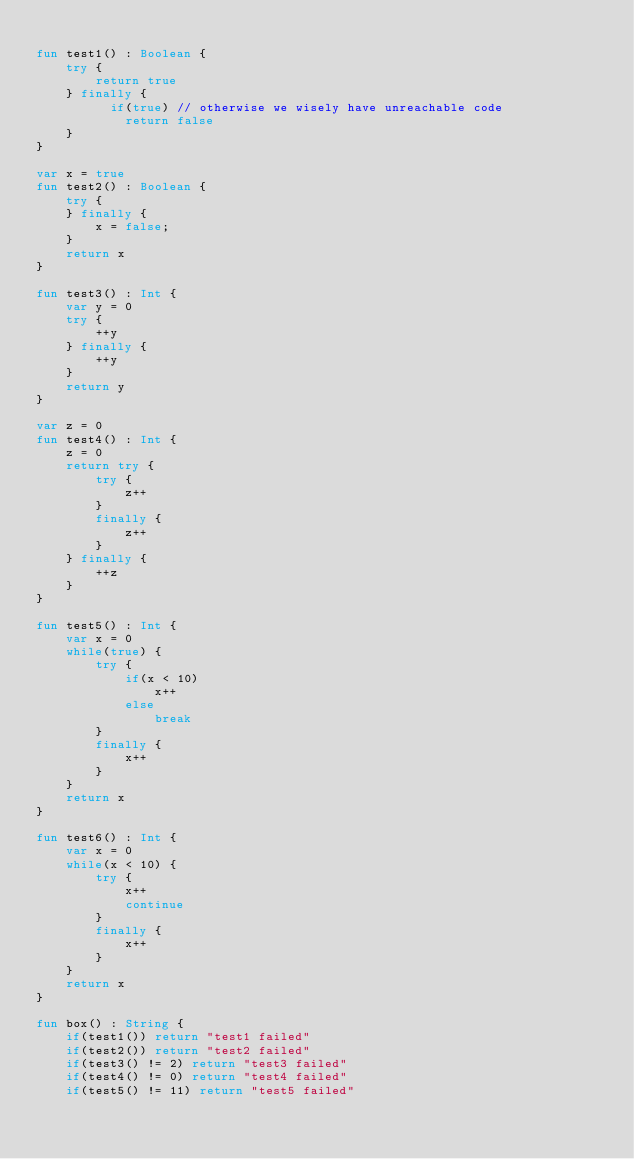Convert code to text. <code><loc_0><loc_0><loc_500><loc_500><_Kotlin_>
fun test1() : Boolean {
    try {
        return true
    } finally {
          if(true) // otherwise we wisely have unreachable code
            return false
    }
}

var x = true
fun test2() : Boolean {
    try {
    } finally {
        x = false;
    }
    return x
}

fun test3() : Int {
    var y = 0
    try {
        ++y
    } finally {
        ++y
    }
    return y
}

var z = 0
fun test4() : Int {
    z = 0
    return try {
        try {
            z++
        }
        finally {
            z++
        }
    } finally {
        ++z
    }
}

fun test5() : Int {
    var x = 0
    while(true) {
        try {
            if(x < 10)
                x++
            else
                break
        }
        finally {
            x++
        }
    }
    return x
}

fun test6() : Int {
    var x = 0
    while(x < 10) {
        try {
            x++
            continue
        }
        finally {
            x++
        }
    }
    return x
}

fun box() : String {
    if(test1()) return "test1 failed"
    if(test2()) return "test2 failed"
    if(test3() != 2) return "test3 failed"
    if(test4() != 0) return "test4 failed"
    if(test5() != 11) return "test5 failed"</code> 